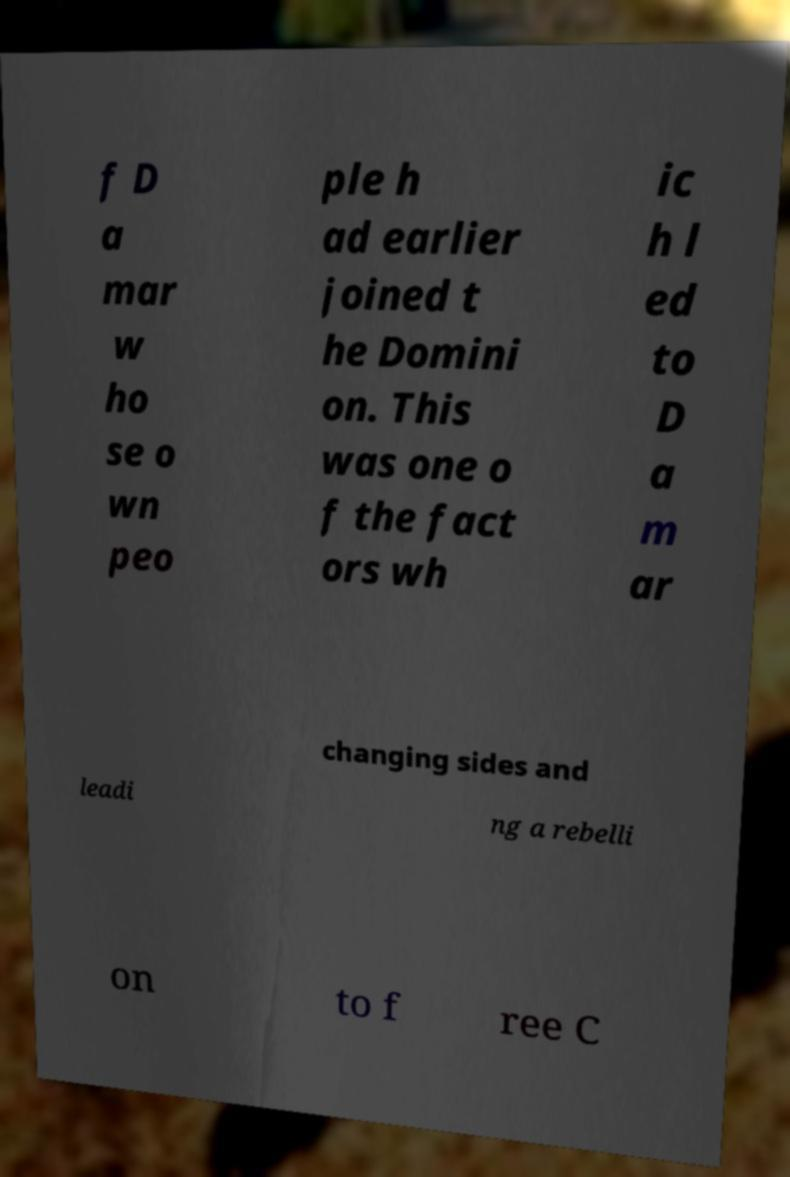Please identify and transcribe the text found in this image. f D a mar w ho se o wn peo ple h ad earlier joined t he Domini on. This was one o f the fact ors wh ic h l ed to D a m ar changing sides and leadi ng a rebelli on to f ree C 